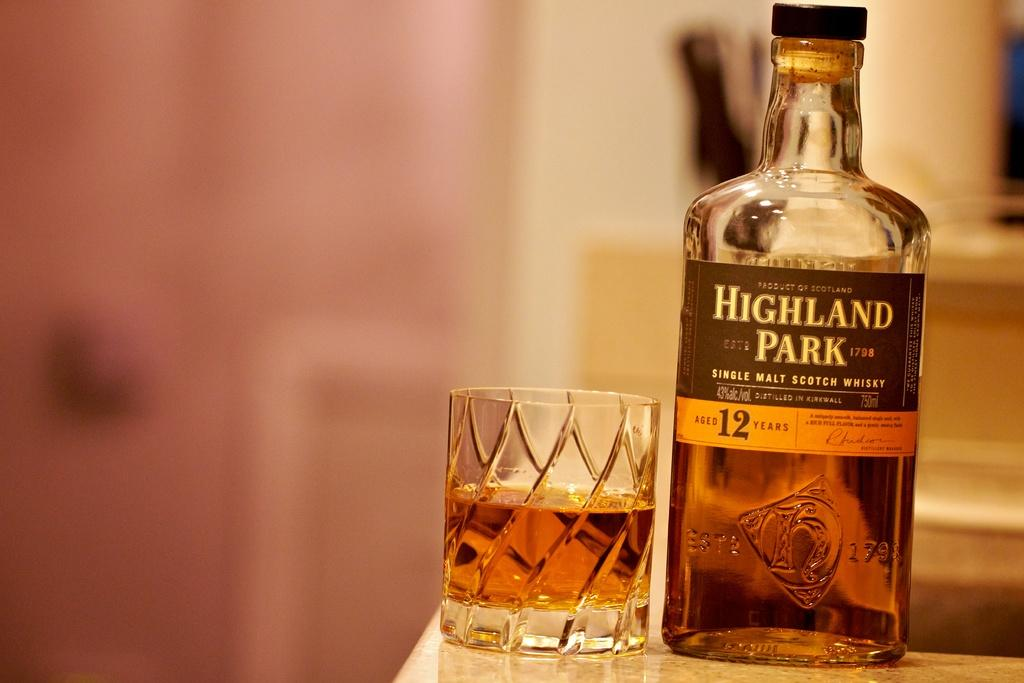What is present in the image that can hold a liquid? There is a bottle and a glass filled with a drink in the image. Can you describe the contents of the glass? The glass is filled with a drink. What type of coal is being used to tan the skin in the image? There is no coal or skin tanning activity present in the image. How many additions are made to the drink in the glass in the image? There is no information about any additions to the drink in the image. 